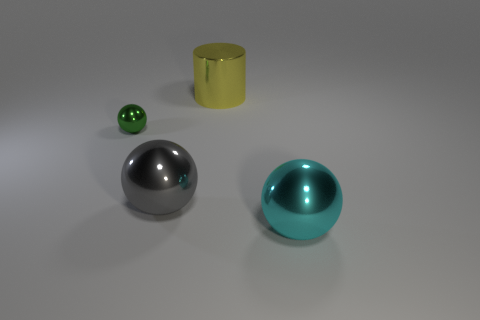There is a thing that is both on the left side of the yellow metal thing and behind the large gray shiny object; what is its material?
Your answer should be compact. Metal. What is the color of the metal sphere behind the big gray metal sphere?
Give a very brief answer. Green. Is the number of metal objects on the right side of the big yellow thing greater than the number of large gray objects?
Provide a succinct answer. No. How many other things are there of the same size as the cyan sphere?
Offer a terse response. 2. What number of gray spheres are left of the tiny green object?
Offer a terse response. 0. Is the number of metal spheres on the right side of the tiny metallic ball the same as the number of small green spheres to the left of the big yellow shiny thing?
Make the answer very short. No. The gray thing that is the same shape as the big cyan shiny thing is what size?
Your response must be concise. Large. The big shiny thing that is in front of the gray metallic thing has what shape?
Offer a very short reply. Sphere. Are the object that is behind the small sphere and the large ball on the right side of the large yellow metallic cylinder made of the same material?
Keep it short and to the point. Yes. The yellow metal object has what shape?
Give a very brief answer. Cylinder. 